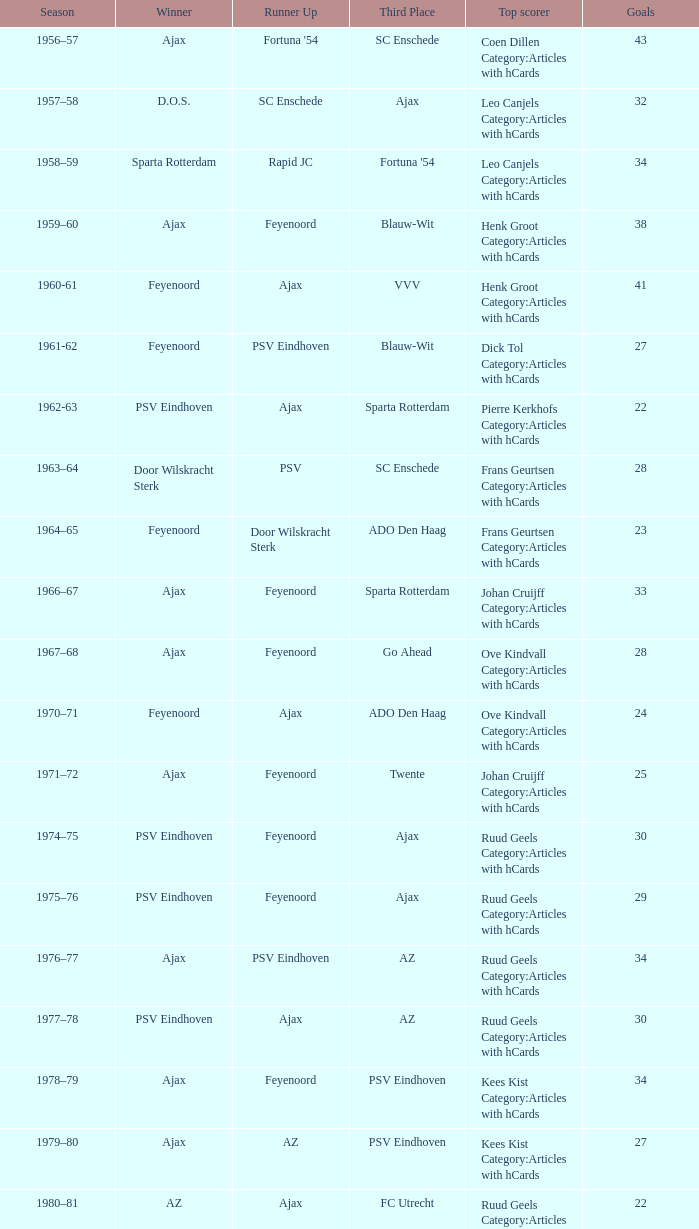When nac breda came in third place and psv eindhoven was the winner who is the top scorer? Klaas-Jan Huntelaar Category:Articles with hCards. 